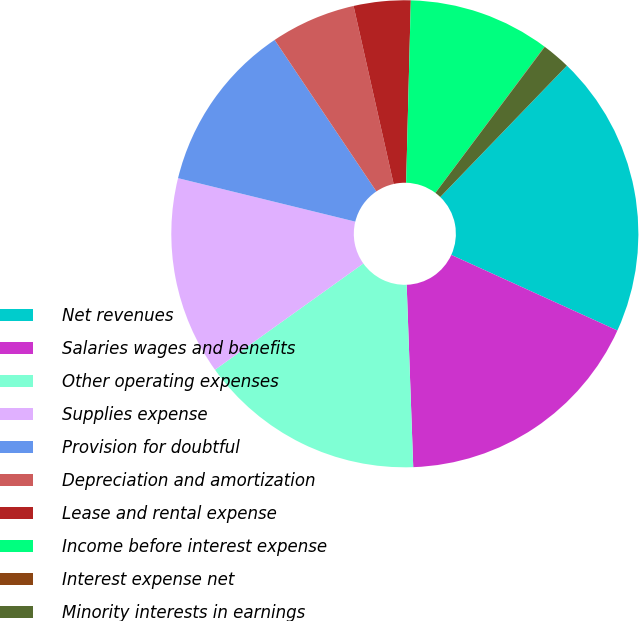<chart> <loc_0><loc_0><loc_500><loc_500><pie_chart><fcel>Net revenues<fcel>Salaries wages and benefits<fcel>Other operating expenses<fcel>Supplies expense<fcel>Provision for doubtful<fcel>Depreciation and amortization<fcel>Lease and rental expense<fcel>Income before interest expense<fcel>Interest expense net<fcel>Minority interests in earnings<nl><fcel>19.59%<fcel>17.63%<fcel>15.68%<fcel>13.72%<fcel>11.76%<fcel>5.89%<fcel>3.93%<fcel>9.8%<fcel>0.02%<fcel>1.98%<nl></chart> 